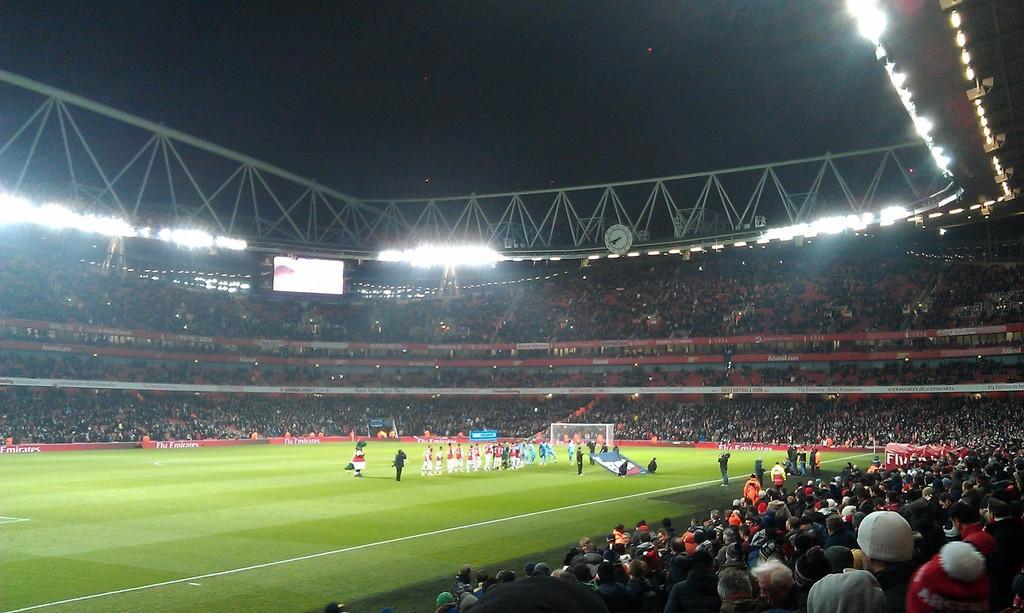Please provide a concise description of this image. In this image we can see a group of people standing on the ground. We can also see some people holding a banner, a goal post and a person wearing a costume. On the backside we can see a group of people sitting beside a fence, a display screen, a clock on the poles, some ceiling lights, boards and the sky with some stars. 